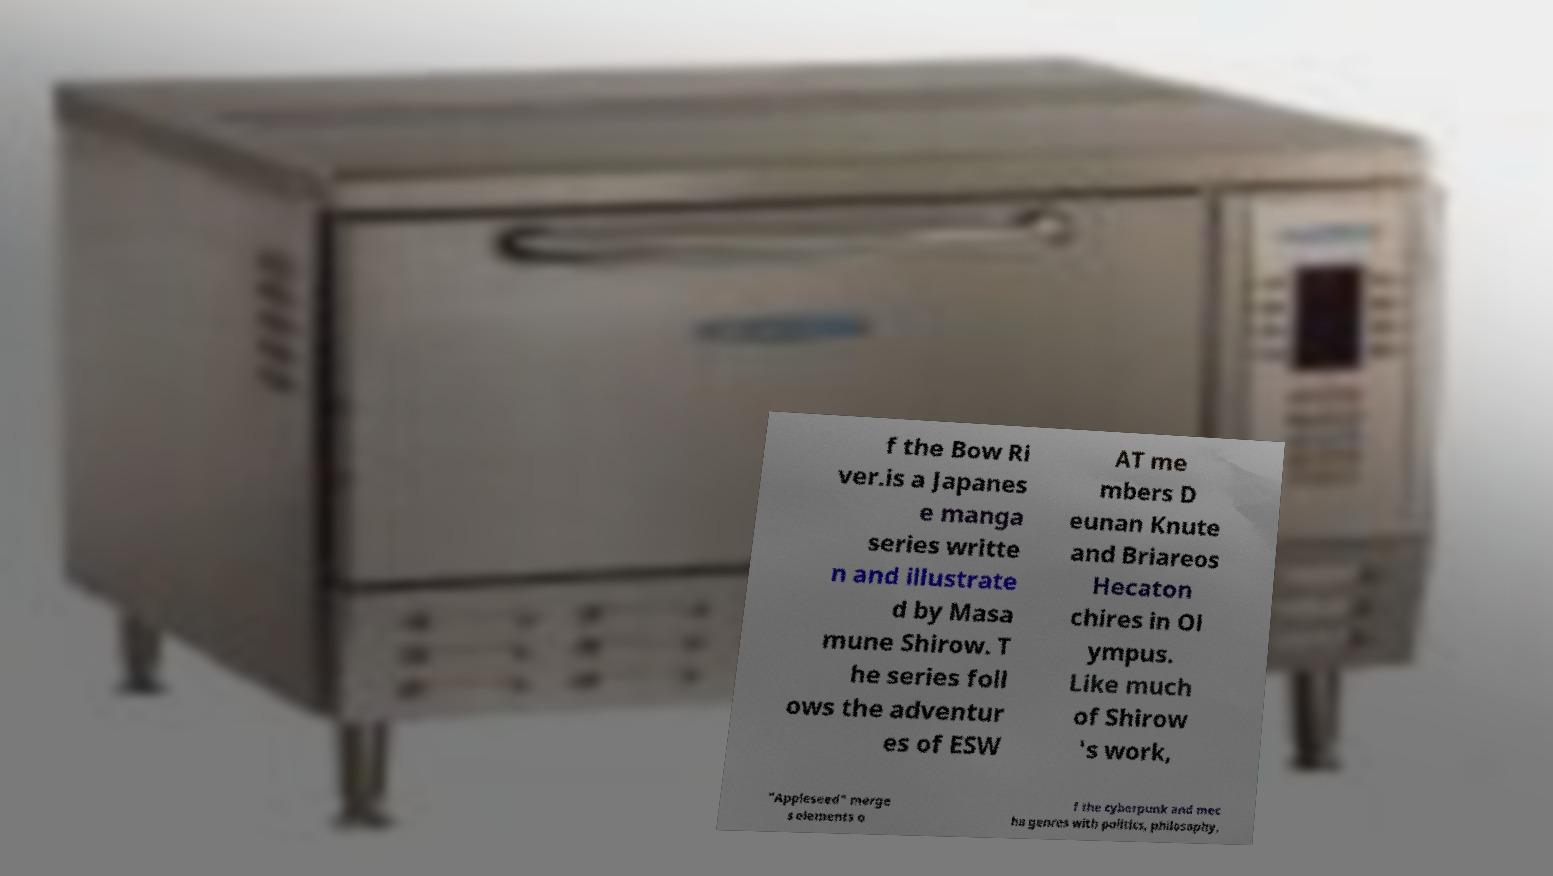I need the written content from this picture converted into text. Can you do that? f the Bow Ri ver.is a Japanes e manga series writte n and illustrate d by Masa mune Shirow. T he series foll ows the adventur es of ESW AT me mbers D eunan Knute and Briareos Hecaton chires in Ol ympus. Like much of Shirow 's work, "Appleseed" merge s elements o f the cyberpunk and mec ha genres with politics, philosophy, 